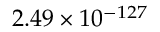Convert formula to latex. <formula><loc_0><loc_0><loc_500><loc_500>2 . 4 9 \times 1 0 ^ { - 1 2 7 }</formula> 